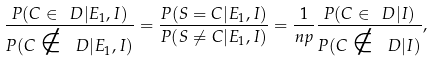<formula> <loc_0><loc_0><loc_500><loc_500>\frac { P ( C \in \ D | E _ { 1 } , I ) } { P ( C \notin \ D | E _ { 1 } , I ) } = \frac { P ( S = C | E _ { 1 } , I ) } { P ( S \neq C | E _ { 1 } , I ) } = \frac { 1 } { n p } \frac { P ( C \in \ D | I ) } { P ( C \notin \ D | I ) } ,</formula> 